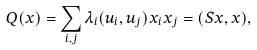<formula> <loc_0><loc_0><loc_500><loc_500>Q ( x ) = \sum _ { i , j } \lambda _ { i } ( u _ { i } , u _ { j } ) x _ { i } x _ { j } = ( S x , x ) ,</formula> 